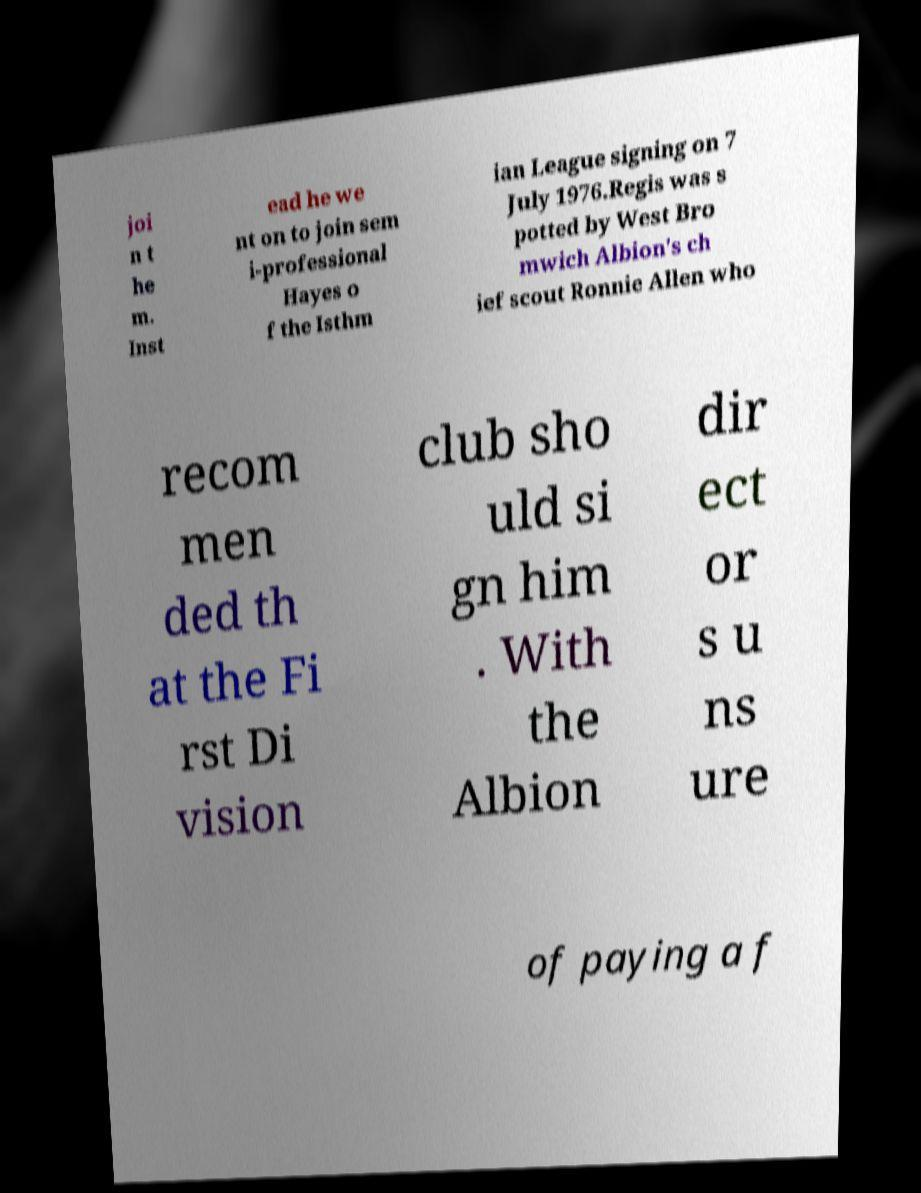Please identify and transcribe the text found in this image. joi n t he m. Inst ead he we nt on to join sem i-professional Hayes o f the Isthm ian League signing on 7 July 1976.Regis was s potted by West Bro mwich Albion's ch ief scout Ronnie Allen who recom men ded th at the Fi rst Di vision club sho uld si gn him . With the Albion dir ect or s u ns ure of paying a f 